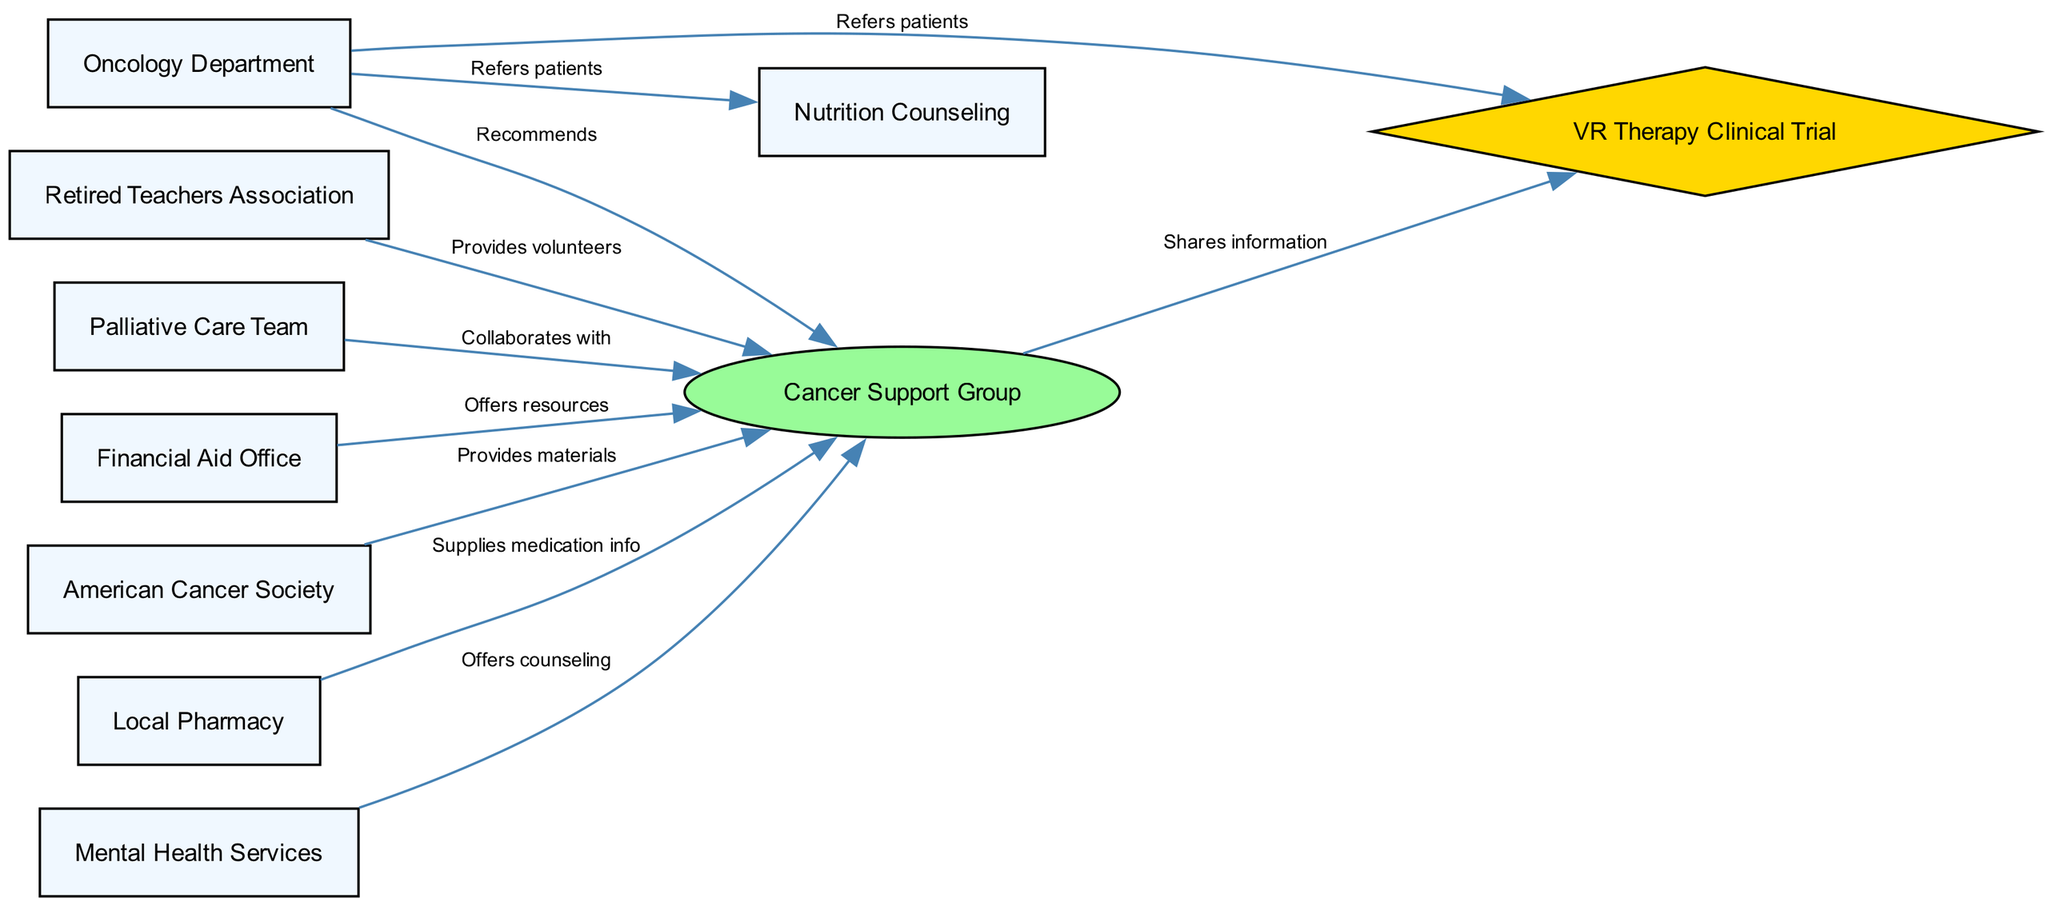What is the total number of nodes in the diagram? The diagram lists nine distinct nodes: VR Therapy Clinical Trial, Oncology Department, Cancer Support Group, Retired Teachers Association, Palliative Care Team, Nutrition Counseling, Financial Aid Office, American Cancer Society, and Local Pharmacy. Counting each unique node gives us a total of nine.
Answer: 9 Which node provides volunteers to the Cancer Support Group? The diagram shows an edge from the Retired Teachers Association to the Cancer Support Group that indicates they provide volunteers. Thus, the Retired Teachers Association is the node that provides volunteers.
Answer: Retired Teachers Association How many services have a direct relationship with the Cancer Support Group? By examining the diagram, we find that there are six nodes that have edges leading to the Cancer Support Group (Oncology Department, Retired Teachers Association, Palliative Care Team, Financial Aid Office, American Cancer Society, and Local Pharmacy). Counting these relationships gives us six services directly connected to the Cancer Support Group.
Answer: 6 What relationship does the Oncology Department have with VR Therapy Clinical Trial? The diagram indicates a directed edge from the Oncology Department to the VR Therapy Clinical Trial labeled "Refers patients". This indicates that the Oncology Department has a referral relationship with the VR Therapy Clinical Trial.
Answer: Refers patients Which node collaborates with the Cancer Support Group? The diagram specifies a directed edge from the Palliative Care Team to the Cancer Support Group, labeled "Collaborates with". Therefore, the Palliative Care Team is the node that collaborates with the Cancer Support Group.
Answer: Palliative Care Team What type of node is the VR Therapy Clinical Trial? In the diagram, the VR Therapy Clinical Trial is highlighted as having a diamond shape, which designates it as a special type of node. This shape indicates its importance in the context as a clinical trial component in the network.
Answer: Diamond How many nodes provide information to the Cancer Support Group? The diagram indicates three nodes that directly supply information to the Cancer Support Group: Mental Health Services (offers counseling), Local Pharmacy (supplies medication info), and the American Cancer Society (provides materials). Counting these gives us three nodes that provide information to the Cancer Support Group.
Answer: 3 Which node is referenced by the Oncology Department? The diagram shows directed edges from the Oncology Department to three nodes: VR Therapy Clinical Trial, Cancer Support Group, and Nutrition Counseling. This indicates that the Oncology Department references all three nodes, but since the question seeks any one, we can identify the first node, which is the VR Therapy Clinical Trial, as one it references.
Answer: VR Therapy Clinical Trial 